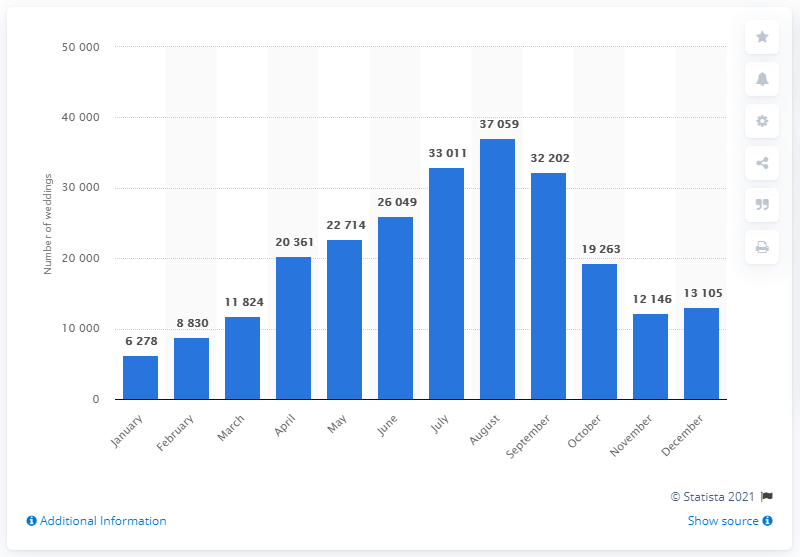Highlight a few significant elements in this photo. August is the most popular month for weddings in England and Wales. According to the information provided, January was the least popular month for weddings in England and Wales. It is estimated that 32,202 weddings took place in September. In August, a total of 37,059 weddings took place. 